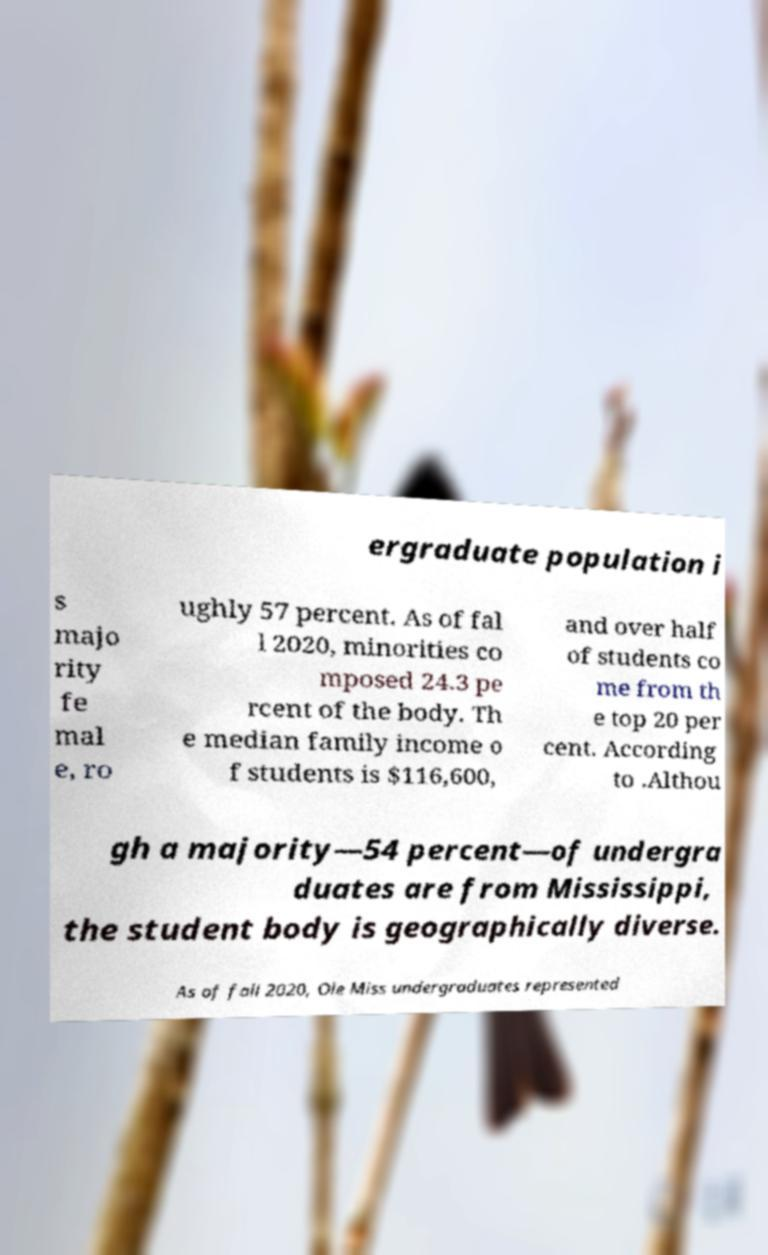For documentation purposes, I need the text within this image transcribed. Could you provide that? ergraduate population i s majo rity fe mal e, ro ughly 57 percent. As of fal l 2020, minorities co mposed 24.3 pe rcent of the body. Th e median family income o f students is $116,600, and over half of students co me from th e top 20 per cent. According to .Althou gh a majority—54 percent—of undergra duates are from Mississippi, the student body is geographically diverse. As of fall 2020, Ole Miss undergraduates represented 